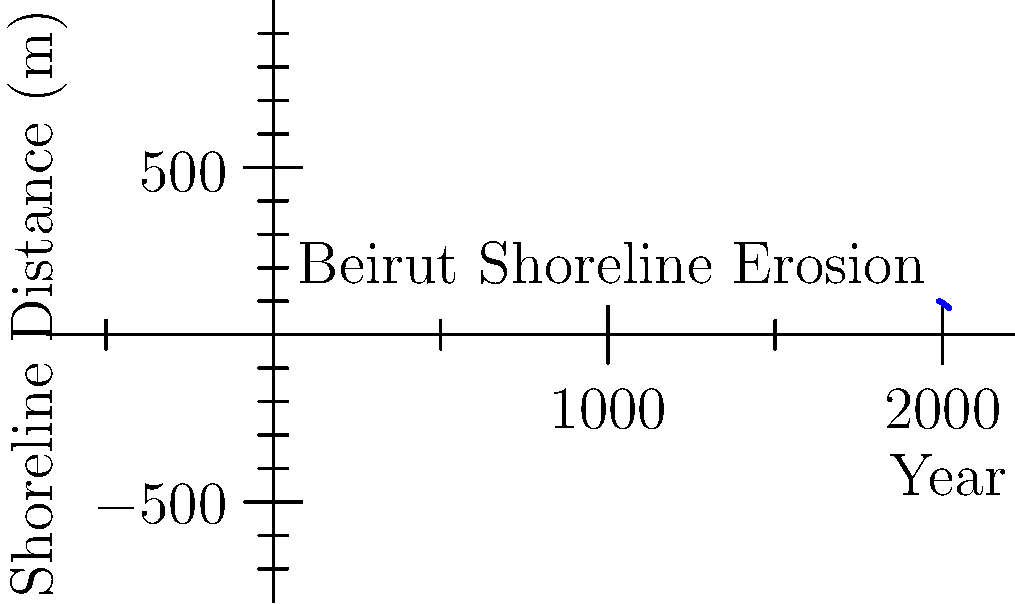Based on the graph showing Beirut's shoreline erosion from 1990 to 2020, calculate the average annual rate of shoreline retreat in meters per year. Assume the trend continues, how many years from 2020 will it take for the shoreline to retreat by an additional 20 meters? 1. Calculate total shoreline retreat:
   Initial distance (1990): 100 m
   Final distance (2020): 80 m
   Total retreat = 100 m - 80 m = 20 m

2. Calculate time period:
   2020 - 1990 = 30 years

3. Calculate average annual rate of retreat:
   Rate = Total retreat / Time period
   Rate = 20 m / 30 years = $\frac{2}{3}$ m/year

4. Calculate time for additional 20 m retreat:
   Time = Additional retreat / Annual rate
   Time = 20 m / ($\frac{2}{3}$ m/year)
   Time = 20 * $\frac{3}{2}$ = 30 years

Therefore, it will take 30 years from 2020 for the shoreline to retreat an additional 20 meters, assuming the trend continues.
Answer: 30 years 